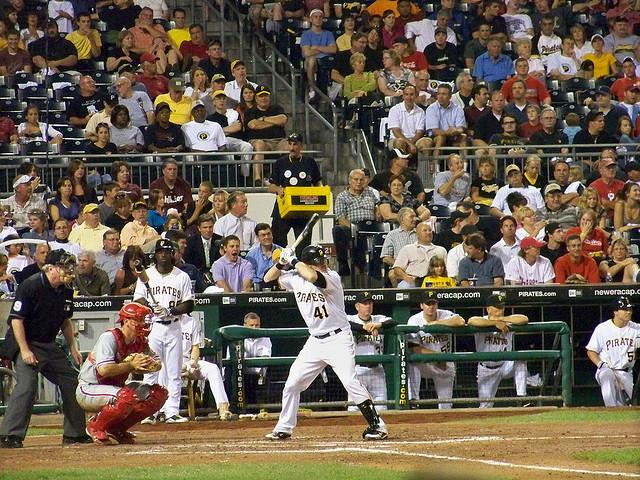What team is shown playing?
Keep it brief. Pirates. What color most stands out in the crowd of people?
Short answer required. White. Are the spectators cheering?
Short answer required. No. Where is number 41?
Answer briefly. Batting. 